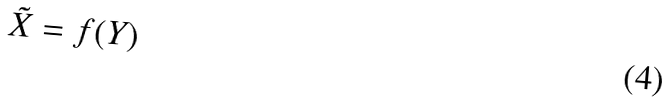<formula> <loc_0><loc_0><loc_500><loc_500>\tilde { X } = f ( Y )</formula> 